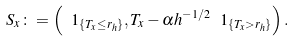<formula> <loc_0><loc_0><loc_500><loc_500>S _ { x } \colon = \left ( \ 1 _ { \{ T _ { x } \leq r _ { h } \} } , T _ { x } - \alpha h ^ { - 1 / 2 } \ 1 _ { \{ T _ { x } > r _ { h } \} } \right ) .</formula> 